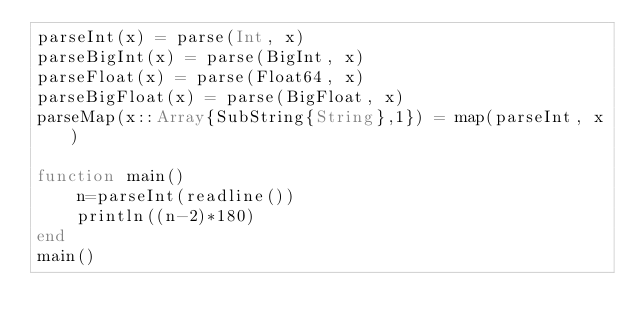<code> <loc_0><loc_0><loc_500><loc_500><_Julia_>parseInt(x) = parse(Int, x)
parseBigInt(x) = parse(BigInt, x)
parseFloat(x) = parse(Float64, x)
parseBigFloat(x) = parse(BigFloat, x)
parseMap(x::Array{SubString{String},1}) = map(parseInt, x)

function main()
    n=parseInt(readline())
    println((n-2)*180)
end
main()</code> 